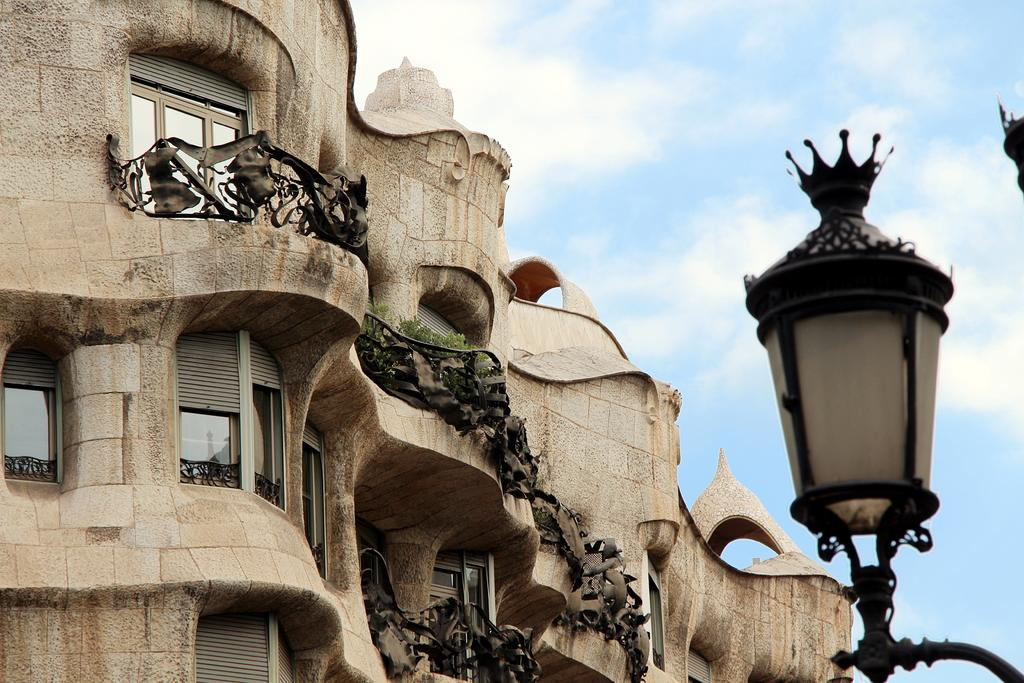What type of structure is visible in the image? There is a building with windows in the image. What feature can be seen on the building? The building has a railing. What else is present in the image besides the building? There are plants and a street lamp on the right side of the image. How would you describe the sky in the image? The sky is visible in the image and appears cloudy. What type of pie is being served on the desk in the image? There is no pie or desk present in the image; it features a building, plants, and a street lamp. What unit of measurement is used to determine the height of the building in the image? The provided facts do not mention any specific unit of measurement for the building's height. 